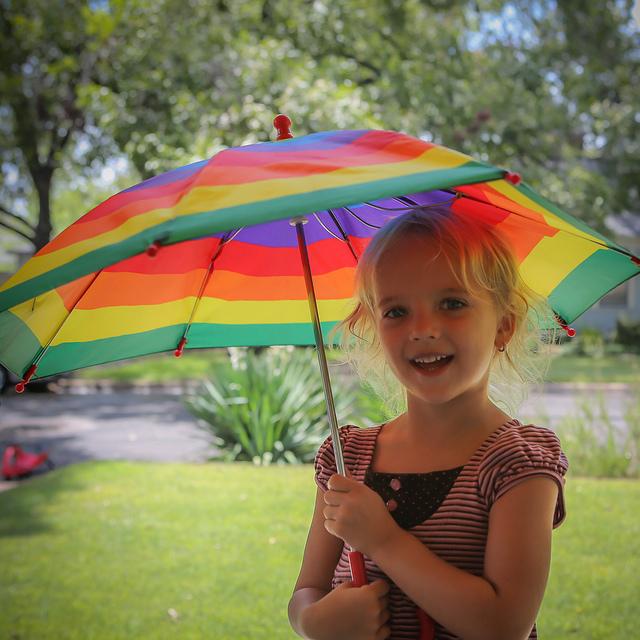Where is the street?
Answer briefly. Behind girl. What color is the umbrella?
Be succinct. Rainbow. Is it several colors?
Concise answer only. Yes. 